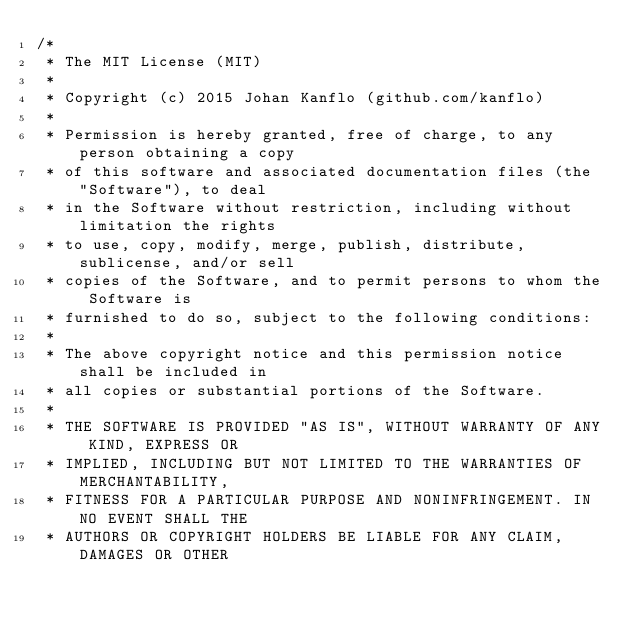<code> <loc_0><loc_0><loc_500><loc_500><_C_>/* 
 * The MIT License (MIT)
 * 
 * Copyright (c) 2015 Johan Kanflo (github.com/kanflo)
 * 
 * Permission is hereby granted, free of charge, to any person obtaining a copy
 * of this software and associated documentation files (the "Software"), to deal
 * in the Software without restriction, including without limitation the rights
 * to use, copy, modify, merge, publish, distribute, sublicense, and/or sell
 * copies of the Software, and to permit persons to whom the Software is
 * furnished to do so, subject to the following conditions:
 * 
 * The above copyright notice and this permission notice shall be included in
 * all copies or substantial portions of the Software.
 * 
 * THE SOFTWARE IS PROVIDED "AS IS", WITHOUT WARRANTY OF ANY KIND, EXPRESS OR
 * IMPLIED, INCLUDING BUT NOT LIMITED TO THE WARRANTIES OF MERCHANTABILITY,
 * FITNESS FOR A PARTICULAR PURPOSE AND NONINFRINGEMENT. IN NO EVENT SHALL THE
 * AUTHORS OR COPYRIGHT HOLDERS BE LIABLE FOR ANY CLAIM, DAMAGES OR OTHER</code> 